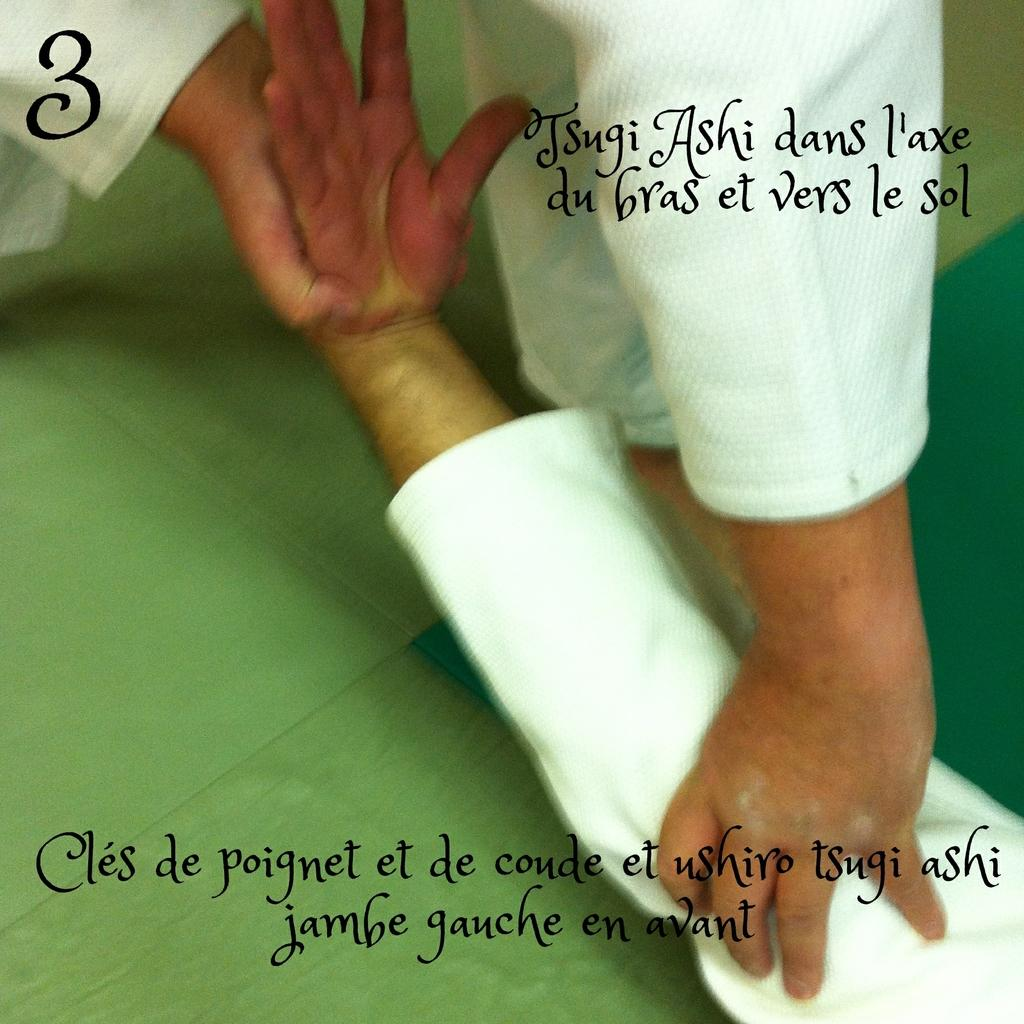What is happening between the two people in the image? There is a person holding another person in the image. What can be seen beneath the people in the image? The ground is visible in the image. Are there any words or letters present in the image? Yes, there is some text present in the image. How many frogs can be seen jumping around the airport in the image? There are no frogs or airports present in the image. What type of system is being used to manage the people in the image? There is no system mentioned or depicted in the image. 